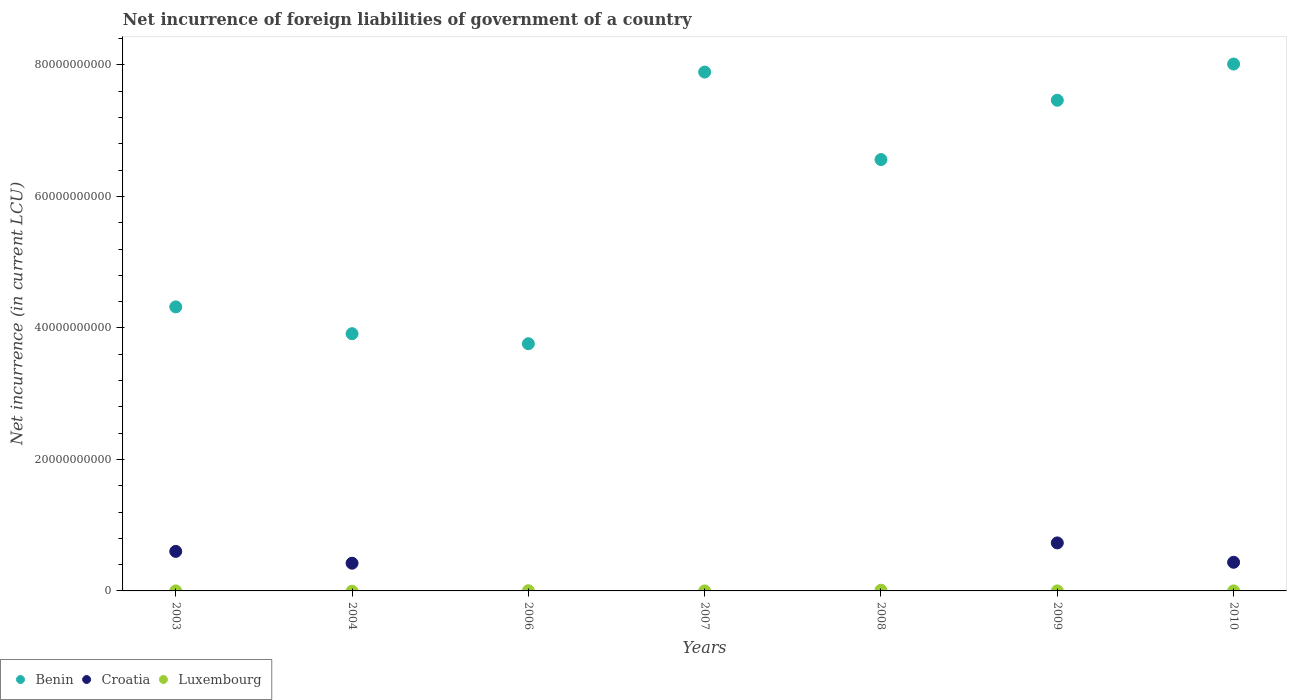How many different coloured dotlines are there?
Keep it short and to the point. 3. What is the net incurrence of foreign liabilities in Luxembourg in 2003?
Give a very brief answer. 3.31e+06. Across all years, what is the maximum net incurrence of foreign liabilities in Benin?
Your answer should be compact. 8.01e+1. Across all years, what is the minimum net incurrence of foreign liabilities in Benin?
Ensure brevity in your answer.  3.76e+1. In which year was the net incurrence of foreign liabilities in Benin maximum?
Offer a terse response. 2010. What is the total net incurrence of foreign liabilities in Croatia in the graph?
Ensure brevity in your answer.  2.19e+1. What is the difference between the net incurrence of foreign liabilities in Benin in 2004 and that in 2008?
Offer a terse response. -2.65e+1. What is the average net incurrence of foreign liabilities in Luxembourg per year?
Your answer should be very brief. 2.15e+07. In the year 2010, what is the difference between the net incurrence of foreign liabilities in Benin and net incurrence of foreign liabilities in Luxembourg?
Your answer should be very brief. 8.01e+1. In how many years, is the net incurrence of foreign liabilities in Benin greater than 72000000000 LCU?
Provide a short and direct response. 3. What is the ratio of the net incurrence of foreign liabilities in Benin in 2007 to that in 2010?
Keep it short and to the point. 0.98. Is the difference between the net incurrence of foreign liabilities in Benin in 2007 and 2009 greater than the difference between the net incurrence of foreign liabilities in Luxembourg in 2007 and 2009?
Offer a terse response. Yes. What is the difference between the highest and the second highest net incurrence of foreign liabilities in Croatia?
Ensure brevity in your answer.  1.29e+09. What is the difference between the highest and the lowest net incurrence of foreign liabilities in Luxembourg?
Keep it short and to the point. 1.07e+08. In how many years, is the net incurrence of foreign liabilities in Benin greater than the average net incurrence of foreign liabilities in Benin taken over all years?
Provide a succinct answer. 4. Is the sum of the net incurrence of foreign liabilities in Luxembourg in 2008 and 2010 greater than the maximum net incurrence of foreign liabilities in Croatia across all years?
Give a very brief answer. No. Is it the case that in every year, the sum of the net incurrence of foreign liabilities in Croatia and net incurrence of foreign liabilities in Luxembourg  is greater than the net incurrence of foreign liabilities in Benin?
Offer a very short reply. No. Does the net incurrence of foreign liabilities in Luxembourg monotonically increase over the years?
Your answer should be very brief. No. Is the net incurrence of foreign liabilities in Luxembourg strictly greater than the net incurrence of foreign liabilities in Benin over the years?
Your answer should be compact. No. How many dotlines are there?
Offer a terse response. 3. How many years are there in the graph?
Provide a short and direct response. 7. What is the difference between two consecutive major ticks on the Y-axis?
Provide a succinct answer. 2.00e+1. How many legend labels are there?
Your answer should be very brief. 3. How are the legend labels stacked?
Provide a succinct answer. Horizontal. What is the title of the graph?
Your answer should be very brief. Net incurrence of foreign liabilities of government of a country. Does "Andorra" appear as one of the legend labels in the graph?
Offer a terse response. No. What is the label or title of the Y-axis?
Provide a succinct answer. Net incurrence (in current LCU). What is the Net incurrence (in current LCU) in Benin in 2003?
Provide a succinct answer. 4.32e+1. What is the Net incurrence (in current LCU) of Croatia in 2003?
Your response must be concise. 6.01e+09. What is the Net incurrence (in current LCU) in Luxembourg in 2003?
Your answer should be compact. 3.31e+06. What is the Net incurrence (in current LCU) in Benin in 2004?
Offer a terse response. 3.91e+1. What is the Net incurrence (in current LCU) of Croatia in 2004?
Keep it short and to the point. 4.22e+09. What is the Net incurrence (in current LCU) of Luxembourg in 2004?
Keep it short and to the point. 0. What is the Net incurrence (in current LCU) in Benin in 2006?
Ensure brevity in your answer.  3.76e+1. What is the Net incurrence (in current LCU) of Luxembourg in 2006?
Your answer should be very brief. 3.03e+07. What is the Net incurrence (in current LCU) in Benin in 2007?
Make the answer very short. 7.89e+1. What is the Net incurrence (in current LCU) of Croatia in 2007?
Offer a terse response. 0. What is the Net incurrence (in current LCU) in Benin in 2008?
Provide a short and direct response. 6.56e+1. What is the Net incurrence (in current LCU) of Luxembourg in 2008?
Your answer should be compact. 1.07e+08. What is the Net incurrence (in current LCU) of Benin in 2009?
Make the answer very short. 7.46e+1. What is the Net incurrence (in current LCU) in Croatia in 2009?
Keep it short and to the point. 7.30e+09. What is the Net incurrence (in current LCU) in Luxembourg in 2009?
Your answer should be compact. 6.20e+06. What is the Net incurrence (in current LCU) of Benin in 2010?
Offer a terse response. 8.01e+1. What is the Net incurrence (in current LCU) of Croatia in 2010?
Give a very brief answer. 4.36e+09. What is the Net incurrence (in current LCU) in Luxembourg in 2010?
Make the answer very short. 3.00e+06. Across all years, what is the maximum Net incurrence (in current LCU) of Benin?
Provide a succinct answer. 8.01e+1. Across all years, what is the maximum Net incurrence (in current LCU) in Croatia?
Your response must be concise. 7.30e+09. Across all years, what is the maximum Net incurrence (in current LCU) of Luxembourg?
Offer a terse response. 1.07e+08. Across all years, what is the minimum Net incurrence (in current LCU) in Benin?
Make the answer very short. 3.76e+1. Across all years, what is the minimum Net incurrence (in current LCU) of Croatia?
Provide a short and direct response. 0. Across all years, what is the minimum Net incurrence (in current LCU) in Luxembourg?
Offer a very short reply. 0. What is the total Net incurrence (in current LCU) in Benin in the graph?
Make the answer very short. 4.19e+11. What is the total Net incurrence (in current LCU) of Croatia in the graph?
Make the answer very short. 2.19e+1. What is the total Net incurrence (in current LCU) of Luxembourg in the graph?
Offer a terse response. 1.51e+08. What is the difference between the Net incurrence (in current LCU) in Benin in 2003 and that in 2004?
Provide a short and direct response. 4.08e+09. What is the difference between the Net incurrence (in current LCU) of Croatia in 2003 and that in 2004?
Offer a terse response. 1.80e+09. What is the difference between the Net incurrence (in current LCU) of Benin in 2003 and that in 2006?
Your response must be concise. 5.60e+09. What is the difference between the Net incurrence (in current LCU) in Luxembourg in 2003 and that in 2006?
Provide a short and direct response. -2.70e+07. What is the difference between the Net incurrence (in current LCU) of Benin in 2003 and that in 2007?
Ensure brevity in your answer.  -3.57e+1. What is the difference between the Net incurrence (in current LCU) of Luxembourg in 2003 and that in 2007?
Ensure brevity in your answer.  2.41e+06. What is the difference between the Net incurrence (in current LCU) in Benin in 2003 and that in 2008?
Ensure brevity in your answer.  -2.24e+1. What is the difference between the Net incurrence (in current LCU) in Luxembourg in 2003 and that in 2008?
Ensure brevity in your answer.  -1.04e+08. What is the difference between the Net incurrence (in current LCU) in Benin in 2003 and that in 2009?
Offer a very short reply. -3.14e+1. What is the difference between the Net incurrence (in current LCU) in Croatia in 2003 and that in 2009?
Provide a succinct answer. -1.29e+09. What is the difference between the Net incurrence (in current LCU) in Luxembourg in 2003 and that in 2009?
Your answer should be very brief. -2.89e+06. What is the difference between the Net incurrence (in current LCU) in Benin in 2003 and that in 2010?
Your answer should be very brief. -3.69e+1. What is the difference between the Net incurrence (in current LCU) in Croatia in 2003 and that in 2010?
Ensure brevity in your answer.  1.66e+09. What is the difference between the Net incurrence (in current LCU) of Luxembourg in 2003 and that in 2010?
Give a very brief answer. 3.12e+05. What is the difference between the Net incurrence (in current LCU) of Benin in 2004 and that in 2006?
Provide a succinct answer. 1.52e+09. What is the difference between the Net incurrence (in current LCU) of Benin in 2004 and that in 2007?
Ensure brevity in your answer.  -3.98e+1. What is the difference between the Net incurrence (in current LCU) of Benin in 2004 and that in 2008?
Offer a very short reply. -2.65e+1. What is the difference between the Net incurrence (in current LCU) of Benin in 2004 and that in 2009?
Keep it short and to the point. -3.55e+1. What is the difference between the Net incurrence (in current LCU) in Croatia in 2004 and that in 2009?
Offer a terse response. -3.09e+09. What is the difference between the Net incurrence (in current LCU) of Benin in 2004 and that in 2010?
Provide a succinct answer. -4.10e+1. What is the difference between the Net incurrence (in current LCU) of Croatia in 2004 and that in 2010?
Make the answer very short. -1.40e+08. What is the difference between the Net incurrence (in current LCU) in Benin in 2006 and that in 2007?
Your answer should be compact. -4.13e+1. What is the difference between the Net incurrence (in current LCU) in Luxembourg in 2006 and that in 2007?
Ensure brevity in your answer.  2.94e+07. What is the difference between the Net incurrence (in current LCU) in Benin in 2006 and that in 2008?
Offer a very short reply. -2.80e+1. What is the difference between the Net incurrence (in current LCU) of Luxembourg in 2006 and that in 2008?
Provide a succinct answer. -7.67e+07. What is the difference between the Net incurrence (in current LCU) of Benin in 2006 and that in 2009?
Keep it short and to the point. -3.70e+1. What is the difference between the Net incurrence (in current LCU) of Luxembourg in 2006 and that in 2009?
Give a very brief answer. 2.41e+07. What is the difference between the Net incurrence (in current LCU) in Benin in 2006 and that in 2010?
Your response must be concise. -4.25e+1. What is the difference between the Net incurrence (in current LCU) in Luxembourg in 2006 and that in 2010?
Your answer should be very brief. 2.73e+07. What is the difference between the Net incurrence (in current LCU) of Benin in 2007 and that in 2008?
Ensure brevity in your answer.  1.33e+1. What is the difference between the Net incurrence (in current LCU) in Luxembourg in 2007 and that in 2008?
Offer a terse response. -1.06e+08. What is the difference between the Net incurrence (in current LCU) of Benin in 2007 and that in 2009?
Make the answer very short. 4.29e+09. What is the difference between the Net incurrence (in current LCU) of Luxembourg in 2007 and that in 2009?
Your response must be concise. -5.30e+06. What is the difference between the Net incurrence (in current LCU) in Benin in 2007 and that in 2010?
Ensure brevity in your answer.  -1.22e+09. What is the difference between the Net incurrence (in current LCU) of Luxembourg in 2007 and that in 2010?
Offer a terse response. -2.10e+06. What is the difference between the Net incurrence (in current LCU) of Benin in 2008 and that in 2009?
Ensure brevity in your answer.  -9.02e+09. What is the difference between the Net incurrence (in current LCU) of Luxembourg in 2008 and that in 2009?
Offer a very short reply. 1.01e+08. What is the difference between the Net incurrence (in current LCU) in Benin in 2008 and that in 2010?
Your response must be concise. -1.45e+1. What is the difference between the Net incurrence (in current LCU) of Luxembourg in 2008 and that in 2010?
Your answer should be compact. 1.04e+08. What is the difference between the Net incurrence (in current LCU) of Benin in 2009 and that in 2010?
Make the answer very short. -5.51e+09. What is the difference between the Net incurrence (in current LCU) of Croatia in 2009 and that in 2010?
Your answer should be very brief. 2.95e+09. What is the difference between the Net incurrence (in current LCU) in Luxembourg in 2009 and that in 2010?
Provide a succinct answer. 3.20e+06. What is the difference between the Net incurrence (in current LCU) in Benin in 2003 and the Net incurrence (in current LCU) in Croatia in 2004?
Offer a very short reply. 3.90e+1. What is the difference between the Net incurrence (in current LCU) of Benin in 2003 and the Net incurrence (in current LCU) of Luxembourg in 2006?
Your answer should be compact. 4.32e+1. What is the difference between the Net incurrence (in current LCU) in Croatia in 2003 and the Net incurrence (in current LCU) in Luxembourg in 2006?
Ensure brevity in your answer.  5.98e+09. What is the difference between the Net incurrence (in current LCU) of Benin in 2003 and the Net incurrence (in current LCU) of Luxembourg in 2007?
Offer a very short reply. 4.32e+1. What is the difference between the Net incurrence (in current LCU) of Croatia in 2003 and the Net incurrence (in current LCU) of Luxembourg in 2007?
Your answer should be very brief. 6.01e+09. What is the difference between the Net incurrence (in current LCU) in Benin in 2003 and the Net incurrence (in current LCU) in Luxembourg in 2008?
Provide a short and direct response. 4.31e+1. What is the difference between the Net incurrence (in current LCU) of Croatia in 2003 and the Net incurrence (in current LCU) of Luxembourg in 2008?
Give a very brief answer. 5.91e+09. What is the difference between the Net incurrence (in current LCU) in Benin in 2003 and the Net incurrence (in current LCU) in Croatia in 2009?
Provide a short and direct response. 3.59e+1. What is the difference between the Net incurrence (in current LCU) in Benin in 2003 and the Net incurrence (in current LCU) in Luxembourg in 2009?
Keep it short and to the point. 4.32e+1. What is the difference between the Net incurrence (in current LCU) of Croatia in 2003 and the Net incurrence (in current LCU) of Luxembourg in 2009?
Provide a succinct answer. 6.01e+09. What is the difference between the Net incurrence (in current LCU) in Benin in 2003 and the Net incurrence (in current LCU) in Croatia in 2010?
Provide a succinct answer. 3.88e+1. What is the difference between the Net incurrence (in current LCU) of Benin in 2003 and the Net incurrence (in current LCU) of Luxembourg in 2010?
Provide a short and direct response. 4.32e+1. What is the difference between the Net incurrence (in current LCU) in Croatia in 2003 and the Net incurrence (in current LCU) in Luxembourg in 2010?
Provide a succinct answer. 6.01e+09. What is the difference between the Net incurrence (in current LCU) in Benin in 2004 and the Net incurrence (in current LCU) in Luxembourg in 2006?
Offer a very short reply. 3.91e+1. What is the difference between the Net incurrence (in current LCU) in Croatia in 2004 and the Net incurrence (in current LCU) in Luxembourg in 2006?
Your answer should be very brief. 4.19e+09. What is the difference between the Net incurrence (in current LCU) of Benin in 2004 and the Net incurrence (in current LCU) of Luxembourg in 2007?
Ensure brevity in your answer.  3.91e+1. What is the difference between the Net incurrence (in current LCU) in Croatia in 2004 and the Net incurrence (in current LCU) in Luxembourg in 2007?
Offer a terse response. 4.22e+09. What is the difference between the Net incurrence (in current LCU) of Benin in 2004 and the Net incurrence (in current LCU) of Luxembourg in 2008?
Provide a succinct answer. 3.90e+1. What is the difference between the Net incurrence (in current LCU) in Croatia in 2004 and the Net incurrence (in current LCU) in Luxembourg in 2008?
Offer a very short reply. 4.11e+09. What is the difference between the Net incurrence (in current LCU) of Benin in 2004 and the Net incurrence (in current LCU) of Croatia in 2009?
Provide a short and direct response. 3.18e+1. What is the difference between the Net incurrence (in current LCU) in Benin in 2004 and the Net incurrence (in current LCU) in Luxembourg in 2009?
Your answer should be compact. 3.91e+1. What is the difference between the Net incurrence (in current LCU) of Croatia in 2004 and the Net incurrence (in current LCU) of Luxembourg in 2009?
Ensure brevity in your answer.  4.21e+09. What is the difference between the Net incurrence (in current LCU) in Benin in 2004 and the Net incurrence (in current LCU) in Croatia in 2010?
Keep it short and to the point. 3.48e+1. What is the difference between the Net incurrence (in current LCU) of Benin in 2004 and the Net incurrence (in current LCU) of Luxembourg in 2010?
Provide a short and direct response. 3.91e+1. What is the difference between the Net incurrence (in current LCU) of Croatia in 2004 and the Net incurrence (in current LCU) of Luxembourg in 2010?
Keep it short and to the point. 4.21e+09. What is the difference between the Net incurrence (in current LCU) of Benin in 2006 and the Net incurrence (in current LCU) of Luxembourg in 2007?
Your answer should be compact. 3.76e+1. What is the difference between the Net incurrence (in current LCU) in Benin in 2006 and the Net incurrence (in current LCU) in Luxembourg in 2008?
Your answer should be very brief. 3.75e+1. What is the difference between the Net incurrence (in current LCU) of Benin in 2006 and the Net incurrence (in current LCU) of Croatia in 2009?
Your answer should be very brief. 3.03e+1. What is the difference between the Net incurrence (in current LCU) in Benin in 2006 and the Net incurrence (in current LCU) in Luxembourg in 2009?
Ensure brevity in your answer.  3.76e+1. What is the difference between the Net incurrence (in current LCU) of Benin in 2006 and the Net incurrence (in current LCU) of Croatia in 2010?
Provide a short and direct response. 3.32e+1. What is the difference between the Net incurrence (in current LCU) of Benin in 2006 and the Net incurrence (in current LCU) of Luxembourg in 2010?
Ensure brevity in your answer.  3.76e+1. What is the difference between the Net incurrence (in current LCU) in Benin in 2007 and the Net incurrence (in current LCU) in Luxembourg in 2008?
Offer a very short reply. 7.88e+1. What is the difference between the Net incurrence (in current LCU) of Benin in 2007 and the Net incurrence (in current LCU) of Croatia in 2009?
Your answer should be compact. 7.16e+1. What is the difference between the Net incurrence (in current LCU) of Benin in 2007 and the Net incurrence (in current LCU) of Luxembourg in 2009?
Offer a terse response. 7.89e+1. What is the difference between the Net incurrence (in current LCU) of Benin in 2007 and the Net incurrence (in current LCU) of Croatia in 2010?
Ensure brevity in your answer.  7.46e+1. What is the difference between the Net incurrence (in current LCU) of Benin in 2007 and the Net incurrence (in current LCU) of Luxembourg in 2010?
Your answer should be very brief. 7.89e+1. What is the difference between the Net incurrence (in current LCU) of Benin in 2008 and the Net incurrence (in current LCU) of Croatia in 2009?
Your answer should be compact. 5.83e+1. What is the difference between the Net incurrence (in current LCU) in Benin in 2008 and the Net incurrence (in current LCU) in Luxembourg in 2009?
Keep it short and to the point. 6.56e+1. What is the difference between the Net incurrence (in current LCU) in Benin in 2008 and the Net incurrence (in current LCU) in Croatia in 2010?
Provide a short and direct response. 6.13e+1. What is the difference between the Net incurrence (in current LCU) in Benin in 2008 and the Net incurrence (in current LCU) in Luxembourg in 2010?
Ensure brevity in your answer.  6.56e+1. What is the difference between the Net incurrence (in current LCU) in Benin in 2009 and the Net incurrence (in current LCU) in Croatia in 2010?
Provide a short and direct response. 7.03e+1. What is the difference between the Net incurrence (in current LCU) of Benin in 2009 and the Net incurrence (in current LCU) of Luxembourg in 2010?
Make the answer very short. 7.46e+1. What is the difference between the Net incurrence (in current LCU) of Croatia in 2009 and the Net incurrence (in current LCU) of Luxembourg in 2010?
Offer a very short reply. 7.30e+09. What is the average Net incurrence (in current LCU) in Benin per year?
Make the answer very short. 5.99e+1. What is the average Net incurrence (in current LCU) in Croatia per year?
Provide a short and direct response. 3.13e+09. What is the average Net incurrence (in current LCU) of Luxembourg per year?
Provide a succinct answer. 2.15e+07. In the year 2003, what is the difference between the Net incurrence (in current LCU) in Benin and Net incurrence (in current LCU) in Croatia?
Offer a very short reply. 3.72e+1. In the year 2003, what is the difference between the Net incurrence (in current LCU) of Benin and Net incurrence (in current LCU) of Luxembourg?
Your answer should be very brief. 4.32e+1. In the year 2003, what is the difference between the Net incurrence (in current LCU) in Croatia and Net incurrence (in current LCU) in Luxembourg?
Keep it short and to the point. 6.01e+09. In the year 2004, what is the difference between the Net incurrence (in current LCU) in Benin and Net incurrence (in current LCU) in Croatia?
Keep it short and to the point. 3.49e+1. In the year 2006, what is the difference between the Net incurrence (in current LCU) of Benin and Net incurrence (in current LCU) of Luxembourg?
Provide a succinct answer. 3.76e+1. In the year 2007, what is the difference between the Net incurrence (in current LCU) of Benin and Net incurrence (in current LCU) of Luxembourg?
Your answer should be very brief. 7.89e+1. In the year 2008, what is the difference between the Net incurrence (in current LCU) in Benin and Net incurrence (in current LCU) in Luxembourg?
Your answer should be very brief. 6.55e+1. In the year 2009, what is the difference between the Net incurrence (in current LCU) in Benin and Net incurrence (in current LCU) in Croatia?
Provide a succinct answer. 6.73e+1. In the year 2009, what is the difference between the Net incurrence (in current LCU) of Benin and Net incurrence (in current LCU) of Luxembourg?
Give a very brief answer. 7.46e+1. In the year 2009, what is the difference between the Net incurrence (in current LCU) in Croatia and Net incurrence (in current LCU) in Luxembourg?
Provide a succinct answer. 7.30e+09. In the year 2010, what is the difference between the Net incurrence (in current LCU) in Benin and Net incurrence (in current LCU) in Croatia?
Offer a terse response. 7.58e+1. In the year 2010, what is the difference between the Net incurrence (in current LCU) in Benin and Net incurrence (in current LCU) in Luxembourg?
Make the answer very short. 8.01e+1. In the year 2010, what is the difference between the Net incurrence (in current LCU) of Croatia and Net incurrence (in current LCU) of Luxembourg?
Make the answer very short. 4.35e+09. What is the ratio of the Net incurrence (in current LCU) in Benin in 2003 to that in 2004?
Keep it short and to the point. 1.1. What is the ratio of the Net incurrence (in current LCU) in Croatia in 2003 to that in 2004?
Make the answer very short. 1.43. What is the ratio of the Net incurrence (in current LCU) of Benin in 2003 to that in 2006?
Your answer should be very brief. 1.15. What is the ratio of the Net incurrence (in current LCU) of Luxembourg in 2003 to that in 2006?
Offer a very short reply. 0.11. What is the ratio of the Net incurrence (in current LCU) of Benin in 2003 to that in 2007?
Offer a terse response. 0.55. What is the ratio of the Net incurrence (in current LCU) of Luxembourg in 2003 to that in 2007?
Your response must be concise. 3.68. What is the ratio of the Net incurrence (in current LCU) in Benin in 2003 to that in 2008?
Your response must be concise. 0.66. What is the ratio of the Net incurrence (in current LCU) in Luxembourg in 2003 to that in 2008?
Give a very brief answer. 0.03. What is the ratio of the Net incurrence (in current LCU) of Benin in 2003 to that in 2009?
Your answer should be very brief. 0.58. What is the ratio of the Net incurrence (in current LCU) of Croatia in 2003 to that in 2009?
Your answer should be very brief. 0.82. What is the ratio of the Net incurrence (in current LCU) of Luxembourg in 2003 to that in 2009?
Provide a short and direct response. 0.53. What is the ratio of the Net incurrence (in current LCU) in Benin in 2003 to that in 2010?
Offer a terse response. 0.54. What is the ratio of the Net incurrence (in current LCU) of Croatia in 2003 to that in 2010?
Provide a short and direct response. 1.38. What is the ratio of the Net incurrence (in current LCU) of Luxembourg in 2003 to that in 2010?
Ensure brevity in your answer.  1.1. What is the ratio of the Net incurrence (in current LCU) of Benin in 2004 to that in 2006?
Provide a short and direct response. 1.04. What is the ratio of the Net incurrence (in current LCU) in Benin in 2004 to that in 2007?
Offer a very short reply. 0.5. What is the ratio of the Net incurrence (in current LCU) of Benin in 2004 to that in 2008?
Offer a very short reply. 0.6. What is the ratio of the Net incurrence (in current LCU) of Benin in 2004 to that in 2009?
Offer a very short reply. 0.52. What is the ratio of the Net incurrence (in current LCU) in Croatia in 2004 to that in 2009?
Provide a succinct answer. 0.58. What is the ratio of the Net incurrence (in current LCU) in Benin in 2004 to that in 2010?
Keep it short and to the point. 0.49. What is the ratio of the Net incurrence (in current LCU) of Croatia in 2004 to that in 2010?
Your answer should be compact. 0.97. What is the ratio of the Net incurrence (in current LCU) in Benin in 2006 to that in 2007?
Make the answer very short. 0.48. What is the ratio of the Net incurrence (in current LCU) in Luxembourg in 2006 to that in 2007?
Ensure brevity in your answer.  33.7. What is the ratio of the Net incurrence (in current LCU) of Benin in 2006 to that in 2008?
Keep it short and to the point. 0.57. What is the ratio of the Net incurrence (in current LCU) of Luxembourg in 2006 to that in 2008?
Ensure brevity in your answer.  0.28. What is the ratio of the Net incurrence (in current LCU) of Benin in 2006 to that in 2009?
Your answer should be very brief. 0.5. What is the ratio of the Net incurrence (in current LCU) of Luxembourg in 2006 to that in 2009?
Keep it short and to the point. 4.89. What is the ratio of the Net incurrence (in current LCU) in Benin in 2006 to that in 2010?
Your response must be concise. 0.47. What is the ratio of the Net incurrence (in current LCU) in Luxembourg in 2006 to that in 2010?
Give a very brief answer. 10.11. What is the ratio of the Net incurrence (in current LCU) in Benin in 2007 to that in 2008?
Your answer should be compact. 1.2. What is the ratio of the Net incurrence (in current LCU) of Luxembourg in 2007 to that in 2008?
Ensure brevity in your answer.  0.01. What is the ratio of the Net incurrence (in current LCU) in Benin in 2007 to that in 2009?
Provide a short and direct response. 1.06. What is the ratio of the Net incurrence (in current LCU) of Luxembourg in 2007 to that in 2009?
Provide a succinct answer. 0.15. What is the ratio of the Net incurrence (in current LCU) in Benin in 2007 to that in 2010?
Your answer should be compact. 0.98. What is the ratio of the Net incurrence (in current LCU) in Luxembourg in 2007 to that in 2010?
Provide a short and direct response. 0.3. What is the ratio of the Net incurrence (in current LCU) of Benin in 2008 to that in 2009?
Ensure brevity in your answer.  0.88. What is the ratio of the Net incurrence (in current LCU) in Luxembourg in 2008 to that in 2009?
Make the answer very short. 17.26. What is the ratio of the Net incurrence (in current LCU) of Benin in 2008 to that in 2010?
Keep it short and to the point. 0.82. What is the ratio of the Net incurrence (in current LCU) of Luxembourg in 2008 to that in 2010?
Your answer should be compact. 35.67. What is the ratio of the Net incurrence (in current LCU) in Benin in 2009 to that in 2010?
Keep it short and to the point. 0.93. What is the ratio of the Net incurrence (in current LCU) in Croatia in 2009 to that in 2010?
Keep it short and to the point. 1.68. What is the ratio of the Net incurrence (in current LCU) in Luxembourg in 2009 to that in 2010?
Your response must be concise. 2.07. What is the difference between the highest and the second highest Net incurrence (in current LCU) in Benin?
Offer a very short reply. 1.22e+09. What is the difference between the highest and the second highest Net incurrence (in current LCU) in Croatia?
Make the answer very short. 1.29e+09. What is the difference between the highest and the second highest Net incurrence (in current LCU) in Luxembourg?
Make the answer very short. 7.67e+07. What is the difference between the highest and the lowest Net incurrence (in current LCU) of Benin?
Offer a terse response. 4.25e+1. What is the difference between the highest and the lowest Net incurrence (in current LCU) of Croatia?
Your response must be concise. 7.30e+09. What is the difference between the highest and the lowest Net incurrence (in current LCU) in Luxembourg?
Keep it short and to the point. 1.07e+08. 